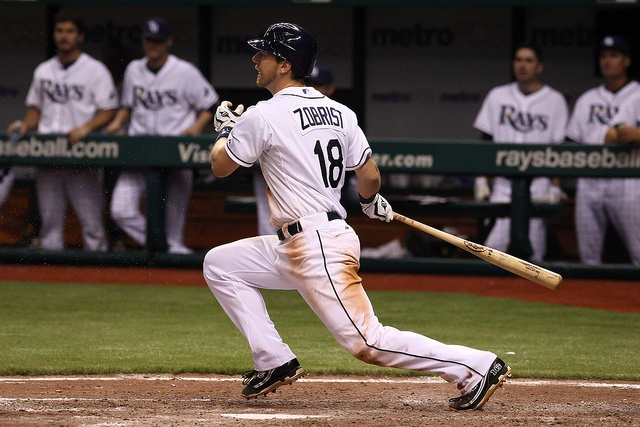Describe the objects in this image and their specific colors. I can see people in black, lavender, darkgray, and gray tones, people in black, gray, darkgray, and lavender tones, people in black, darkgray, and gray tones, people in black, darkgray, gray, and lavender tones, and people in black, darkgray, maroon, and gray tones in this image. 